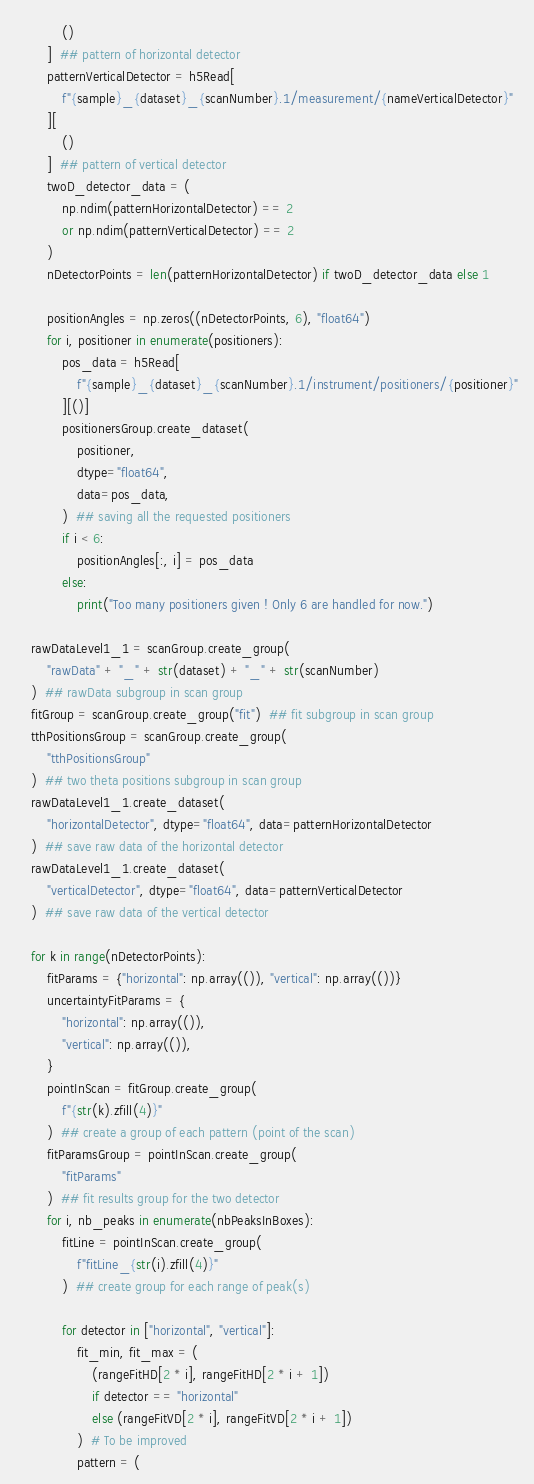<code> <loc_0><loc_0><loc_500><loc_500><_Python_>            ()
        ]  ## pattern of horizontal detector
        patternVerticalDetector = h5Read[
            f"{sample}_{dataset}_{scanNumber}.1/measurement/{nameVerticalDetector}"
        ][
            ()
        ]  ## pattern of vertical detector
        twoD_detector_data = (
            np.ndim(patternHorizontalDetector) == 2
            or np.ndim(patternVerticalDetector) == 2
        )
        nDetectorPoints = len(patternHorizontalDetector) if twoD_detector_data else 1

        positionAngles = np.zeros((nDetectorPoints, 6), "float64")
        for i, positioner in enumerate(positioners):
            pos_data = h5Read[
                f"{sample}_{dataset}_{scanNumber}.1/instrument/positioners/{positioner}"
            ][()]
            positionersGroup.create_dataset(
                positioner,
                dtype="float64",
                data=pos_data,
            )  ## saving all the requested positioners
            if i < 6:
                positionAngles[:, i] = pos_data
            else:
                print("Too many positioners given ! Only 6 are handled for now.")

    rawDataLevel1_1 = scanGroup.create_group(
        "rawData" + "_" + str(dataset) + "_" + str(scanNumber)
    )  ## rawData subgroup in scan group
    fitGroup = scanGroup.create_group("fit")  ## fit subgroup in scan group
    tthPositionsGroup = scanGroup.create_group(
        "tthPositionsGroup"
    )  ## two theta positions subgroup in scan group
    rawDataLevel1_1.create_dataset(
        "horizontalDetector", dtype="float64", data=patternHorizontalDetector
    )  ## save raw data of the horizontal detector
    rawDataLevel1_1.create_dataset(
        "verticalDetector", dtype="float64", data=patternVerticalDetector
    )  ## save raw data of the vertical detector

    for k in range(nDetectorPoints):
        fitParams = {"horizontal": np.array(()), "vertical": np.array(())}
        uncertaintyFitParams = {
            "horizontal": np.array(()),
            "vertical": np.array(()),
        }
        pointInScan = fitGroup.create_group(
            f"{str(k).zfill(4)}"
        )  ## create a group of each pattern (point of the scan)
        fitParamsGroup = pointInScan.create_group(
            "fitParams"
        )  ## fit results group for the two detector
        for i, nb_peaks in enumerate(nbPeaksInBoxes):
            fitLine = pointInScan.create_group(
                f"fitLine_{str(i).zfill(4)}"
            )  ## create group for each range of peak(s)

            for detector in ["horizontal", "vertical"]:
                fit_min, fit_max = (
                    (rangeFitHD[2 * i], rangeFitHD[2 * i + 1])
                    if detector == "horizontal"
                    else (rangeFitVD[2 * i], rangeFitVD[2 * i + 1])
                )  # To be improved
                pattern = (</code> 